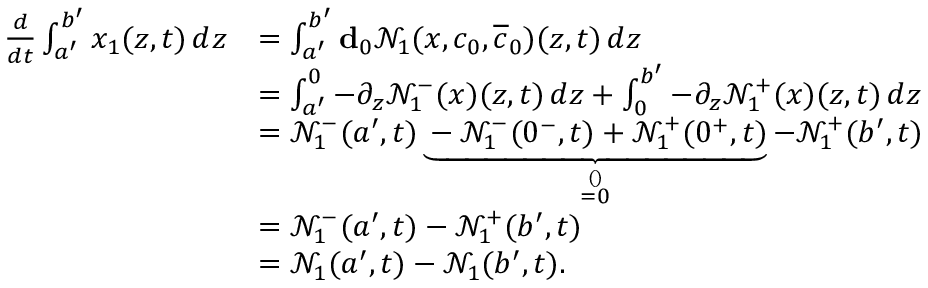Convert formula to latex. <formula><loc_0><loc_0><loc_500><loc_500>\begin{array} { r l } { \frac { d } { d t } \int _ { a ^ { \prime } } ^ { b ^ { \prime } } x _ { 1 } ( z , t ) \, d z } & { = \int _ { a ^ { \prime } } ^ { b ^ { \prime } } d _ { 0 } \mathcal { N } _ { 1 } ( x , c _ { 0 } , \overline { c } _ { 0 } ) ( z , t ) \, d z \, } \\ & { = \int _ { a ^ { \prime } } ^ { 0 } - \partial _ { z } \mathcal { N } _ { 1 } ^ { - } ( x ) ( z , t ) \, d z + \int _ { 0 } ^ { b ^ { \prime } } - \partial _ { z } \mathcal { N } _ { 1 } ^ { + } ( x ) ( z , t ) \, d z } \\ & { = \mathcal { N } _ { 1 } ^ { - } ( a ^ { \prime } , t ) \underbrace { - \mathcal { N } _ { 1 } ^ { - } ( 0 ^ { - } , t ) + \mathcal { N } _ { 1 } ^ { + } ( 0 ^ { + } , t ) } _ { \stackrel { ( ) } { = 0 } } - \mathcal { N } _ { 1 } ^ { + } ( b ^ { \prime } , t ) } \\ & { = \mathcal { N } _ { 1 } ^ { - } ( a ^ { \prime } , t ) - \mathcal { N } _ { 1 } ^ { + } ( b ^ { \prime } , t ) } \\ & { = \mathcal { N } _ { 1 } ( a ^ { \prime } , t ) - \mathcal { N } _ { 1 } ( b ^ { \prime } , t ) . } \end{array}</formula> 